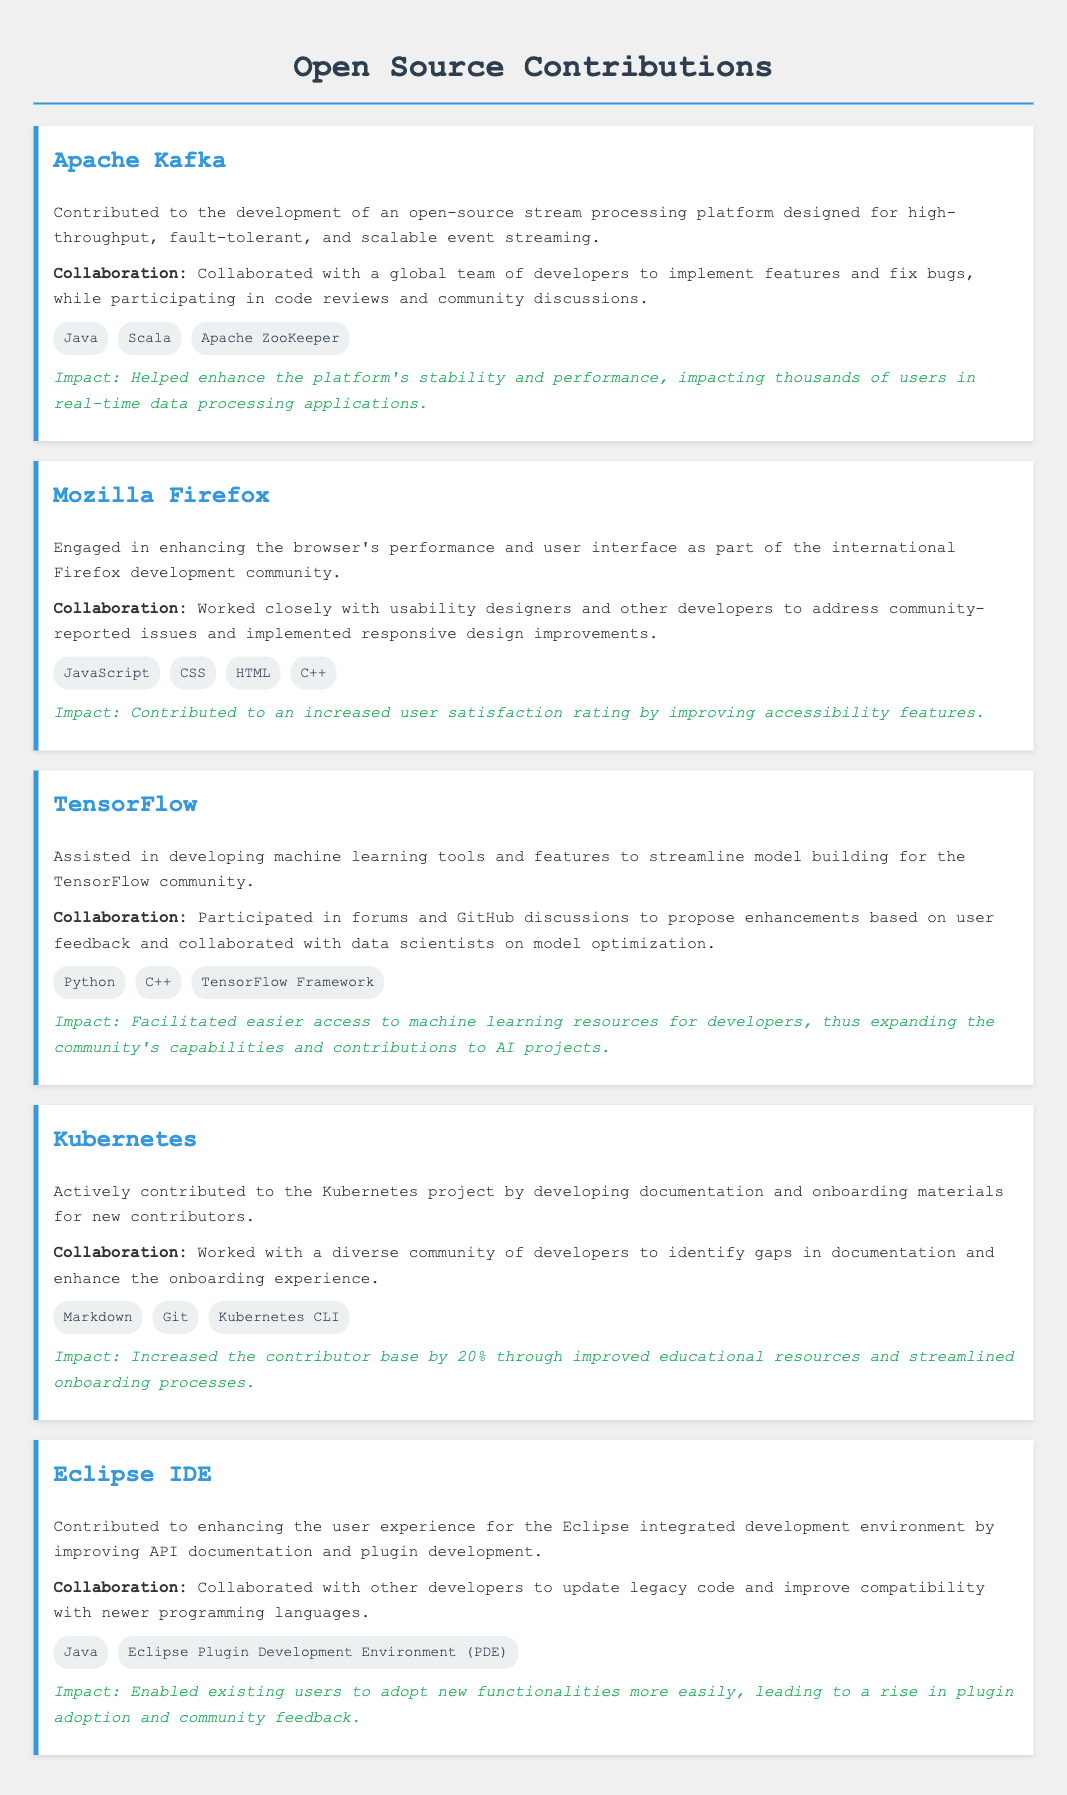what is one technology used in Apache Kafka? The document lists Java, Scala, and Apache ZooKeeper as technologies used in Apache Kafka.
Answer: Java who collaborated with developers for Mozilla Firefox? The document states that usability designers and other developers collaborated to enhance the browser.
Answer: usability designers what was the impact of contributions to TensorFlow? The document mentions facilitating easier access to machine learning resources for developers as an impact of contributions to TensorFlow.
Answer: easier access what is the increase in the contributor base for Kubernetes? The document states that contributions led to a 20% increase in the contributor base for Kubernetes.
Answer: 20% which project involved enhancing API documentation? The document mentions Eclipse IDE for enhancing API documentation.
Answer: Eclipse IDE what programming languages were improved for Eclipse IDE? The document states that compatibility with newer programming languages was improved in Eclipse IDE.
Answer: newer programming languages how did contributions to Mozilla Firefox affect user satisfaction? The document states that user satisfaction ratings increased as a result of contributions to Mozilla Firefox.
Answer: increased user satisfaction what type of materials were developed for Kubernetes? The document mentions developing documentation and onboarding materials for new contributors to Kubernetes.
Answer: documentation and onboarding materials what is one programming language used in TensorFlow contributions? The document lists Python and C++ as technologies used in TensorFlow contributions.
Answer: Python 